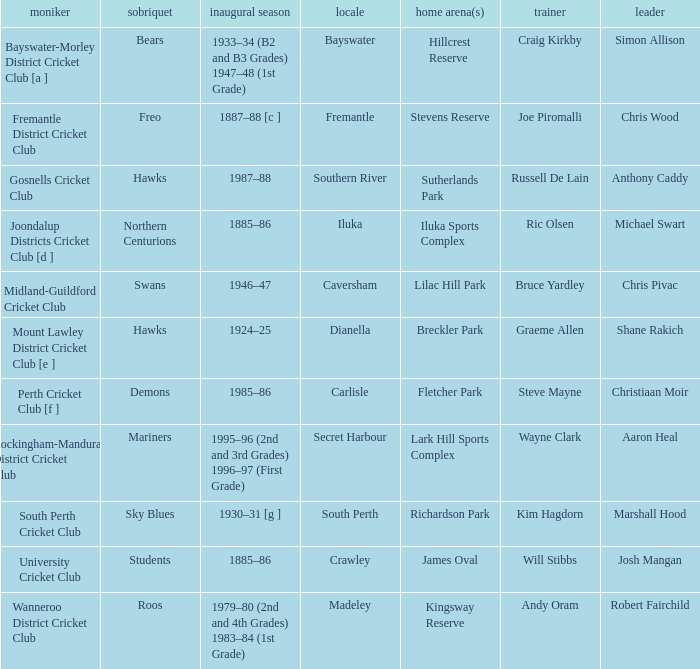In which place is the bears club situated? Bayswater. 